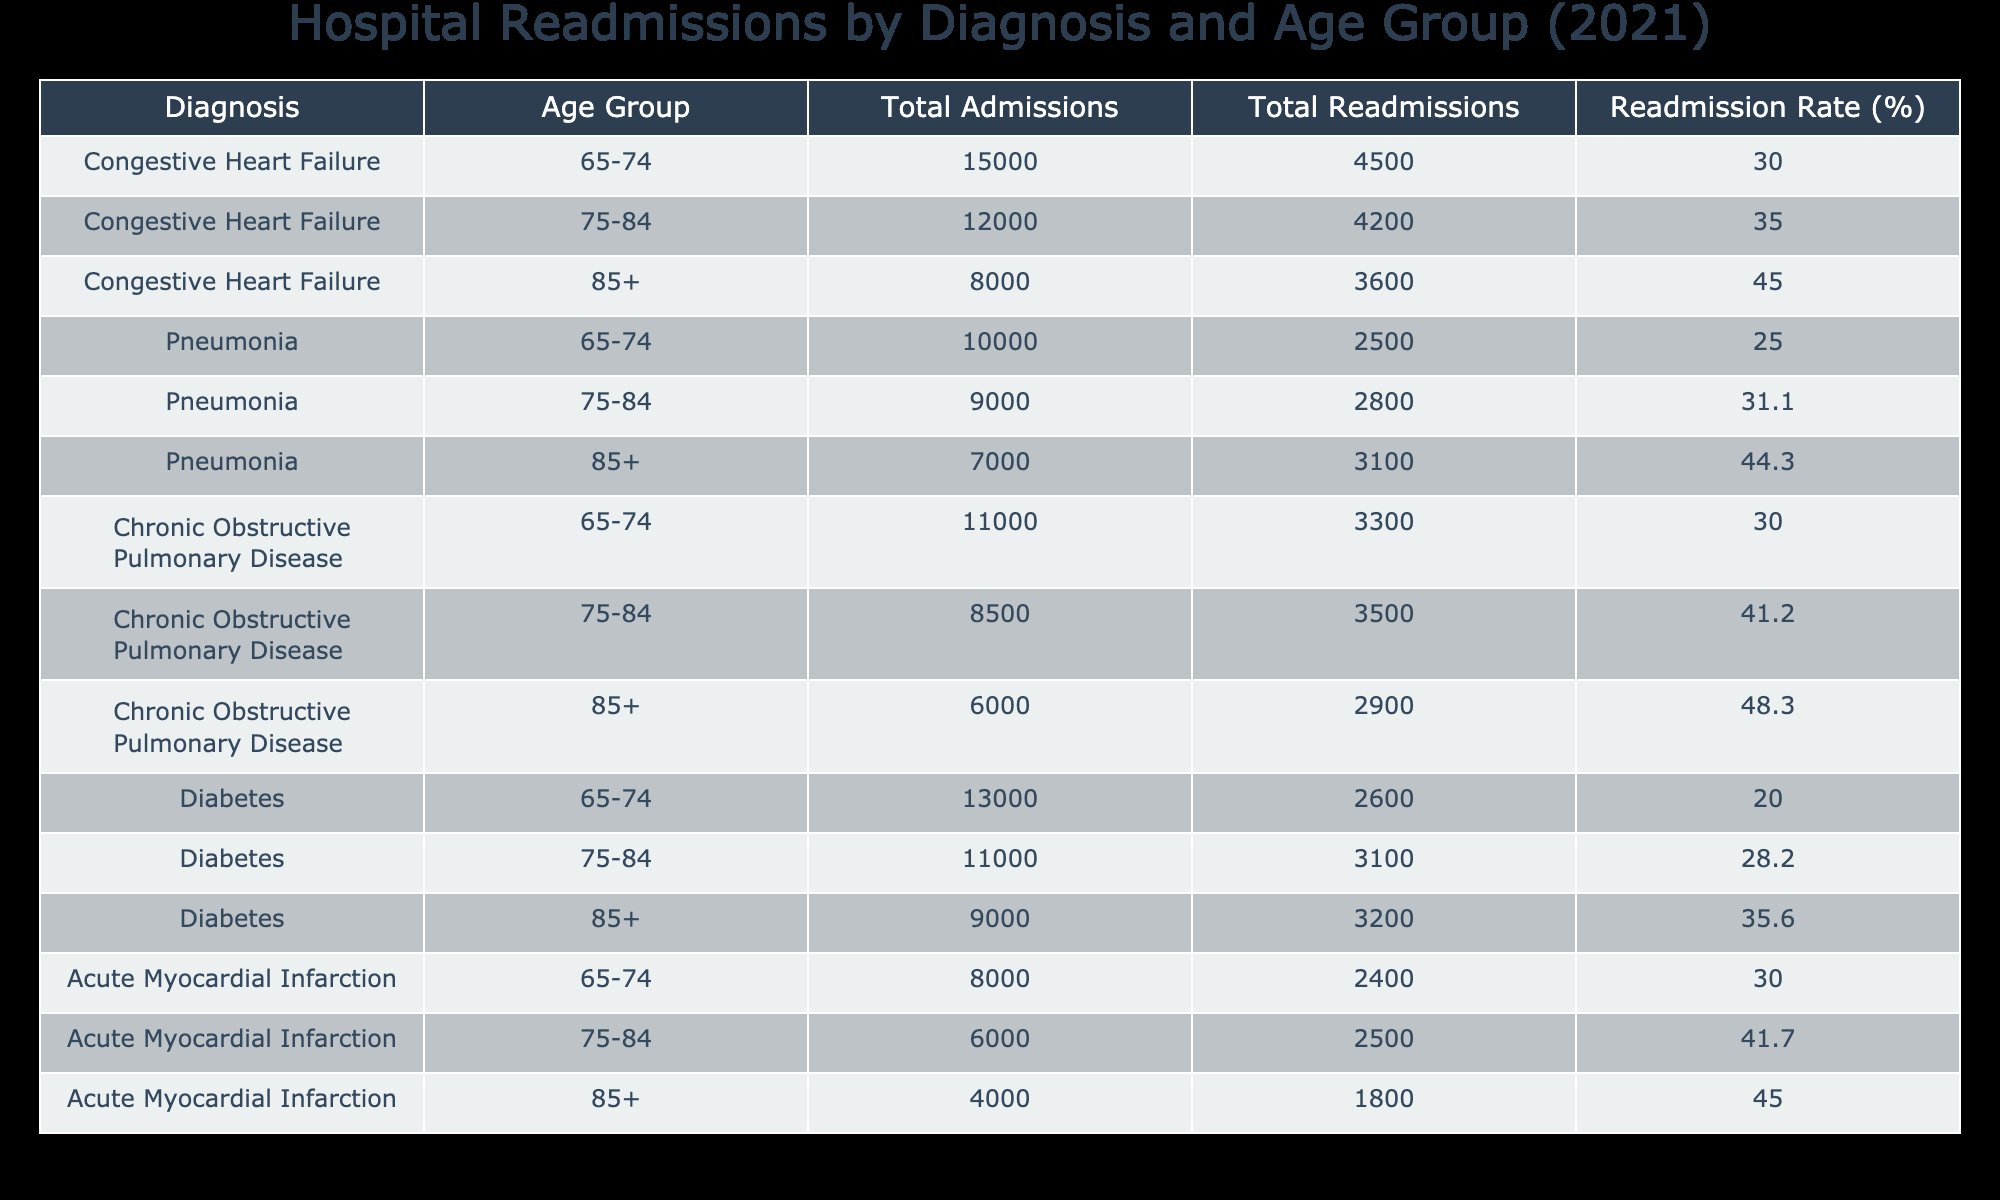What is the readmission rate for patients aged 75-84 with Chronic Obstructive Pulmonary Disease? The readmission rate for this group can be found in the table under the corresponding diagnosis and age group. It shows a readmission rate of 41.2%.
Answer: 41.2% Which diagnosis has the highest readmission rate in the age group 85+? By comparing the readmission rates for all diagnoses in the 85+ age group from the table, Chronic Obstructive Pulmonary Disease has the highest rate at 48.3%.
Answer: Chronic Obstructive Pulmonary Disease How many total readmissions occurred for Pneumonia in the age group 65-74? Looking at the table for Pneumonia in the age group 65-74, the total readmissions are listed as 2500.
Answer: 2500 What is the average total admissions for all diagnoses in the age group 75-84? To find the average total admissions for the 75-84 age group, we first add the total admissions for this age group across all diagnoses: 12000 + 9000 + 8500 + 11000 + 6000 = 49500. There are 5 diagnoses, so the average is 49500 / 5 = 9900.
Answer: 9900 Is the readmission rate for Diabetes in the age group 65-74 higher than 25%? The readmission rate for Diabetes in the age group 65-74 is 20.0%. Since this is less than 25%, the answer is no.
Answer: No What is the difference in total admissions between patients aged 75-84 with Congestive Heart Failure and those with Diabetes? The total admissions for Congestive Heart Failure (75-84) is 12000 and for Diabetes (75-84) is 11000. The difference is 12000 - 11000 = 1000.
Answer: 1000 For which age group is the readmission rate for Acute Myocardial Infarction the lowest? The readmission rates for Acute Myocardial Infarction are 30.0% (65-74), 41.7% (75-84), and 45.0% (85+). The lowest rate is 30.0% for the age group 65-74.
Answer: 65-74 If we combine the total readmissions for all diagnoses in the age group 85+, what would the total be? To find the total readmissions for the 85+ age group, we add the readmissions for each diagnosis: 3600 (CHF) + 3100 (Pneumonia) + 2900 (COPD) + 3200 (Diabetes) + 1800 (AMI) = 14600.
Answer: 14600 Are there more total readmissions for Pneumonia than for Diabetes across all age groups? The total readmissions can be summed for each diagnosis: Pneumonia has a total of 2500 (65-74) + 2800 (75-84) + 3100 (85+) = 8400, while Diabetes has 2600 (65-74) + 3100 (75-84) + 3200 (85+) = 8900. Since 8400 is less than 8900, the answer is no.
Answer: No 